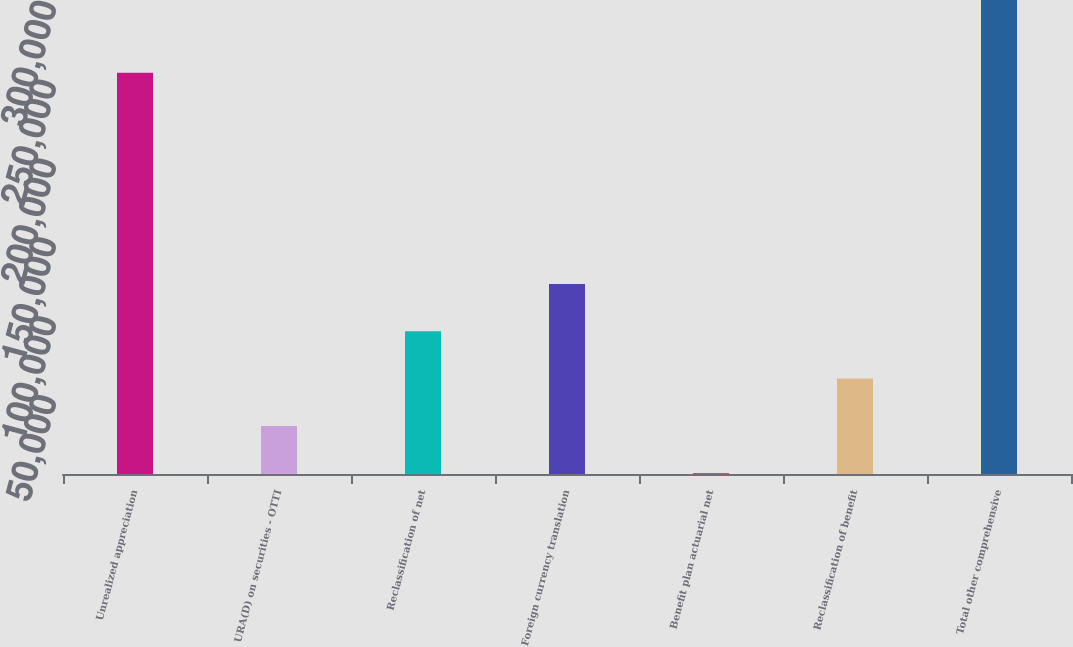<chart> <loc_0><loc_0><loc_500><loc_500><bar_chart><fcel>Unrealized appreciation<fcel>URA(D) on securities - OTTI<fcel>Reclassification of net<fcel>Foreign currency translation<fcel>Benefit plan actuarial net<fcel>Reclassification of benefit<fcel>Total other comprehensive<nl><fcel>254450<fcel>30505.5<fcel>90496.5<fcel>120492<fcel>510<fcel>60501<fcel>300465<nl></chart> 